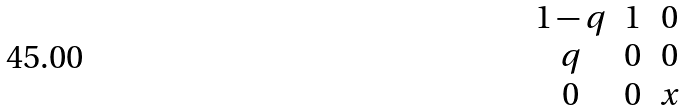<formula> <loc_0><loc_0><loc_500><loc_500>\begin{matrix} 1 - q & 1 & 0 \\ q & 0 & 0 \\ 0 & 0 & x \\ \end{matrix}</formula> 